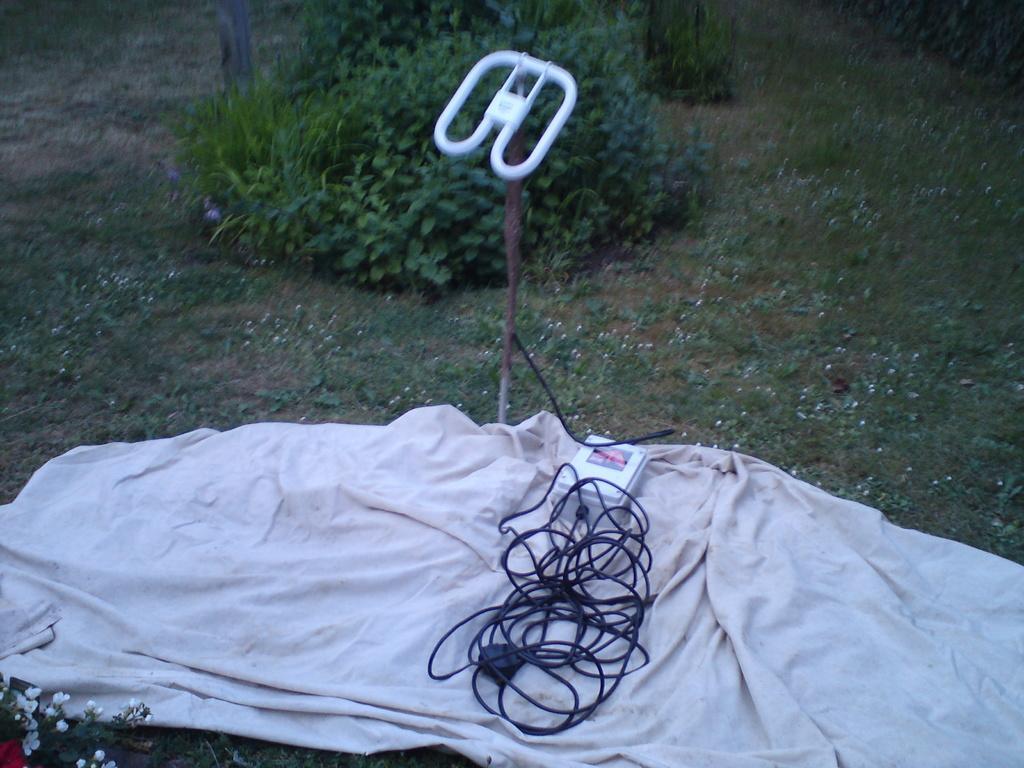Please provide a concise description of this image. In this image we can see some plants, flowers, there is a cloth on the ground, wire is connected to electric box, also we can see handle, wooden stick, and grass. 